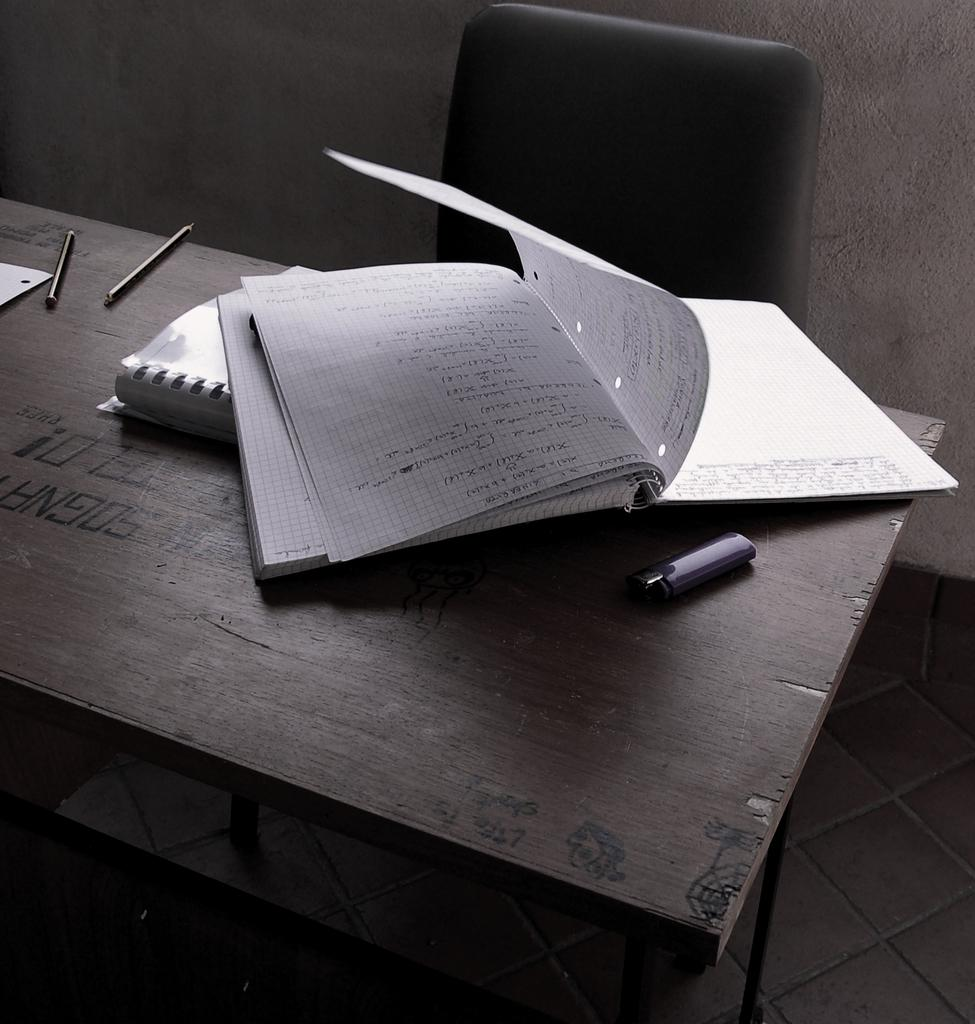<image>
Write a terse but informative summary of the picture. A notebook sits on a table with the word Sogna burned into it. 